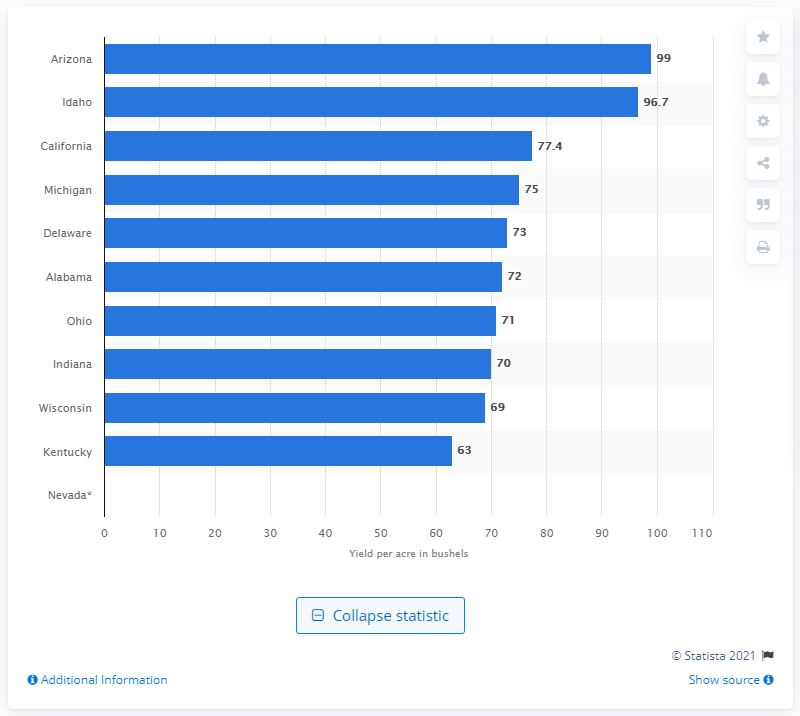Specify some key components in this picture. The wheat yield per acre in Arizona in 2020 was 99. 